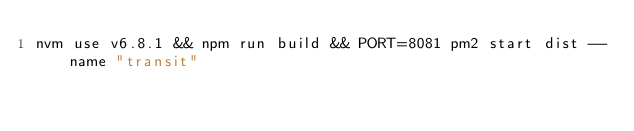<code> <loc_0><loc_0><loc_500><loc_500><_Bash_>nvm use v6.8.1 && npm run build && PORT=8081 pm2 start dist --name "transit"
</code> 